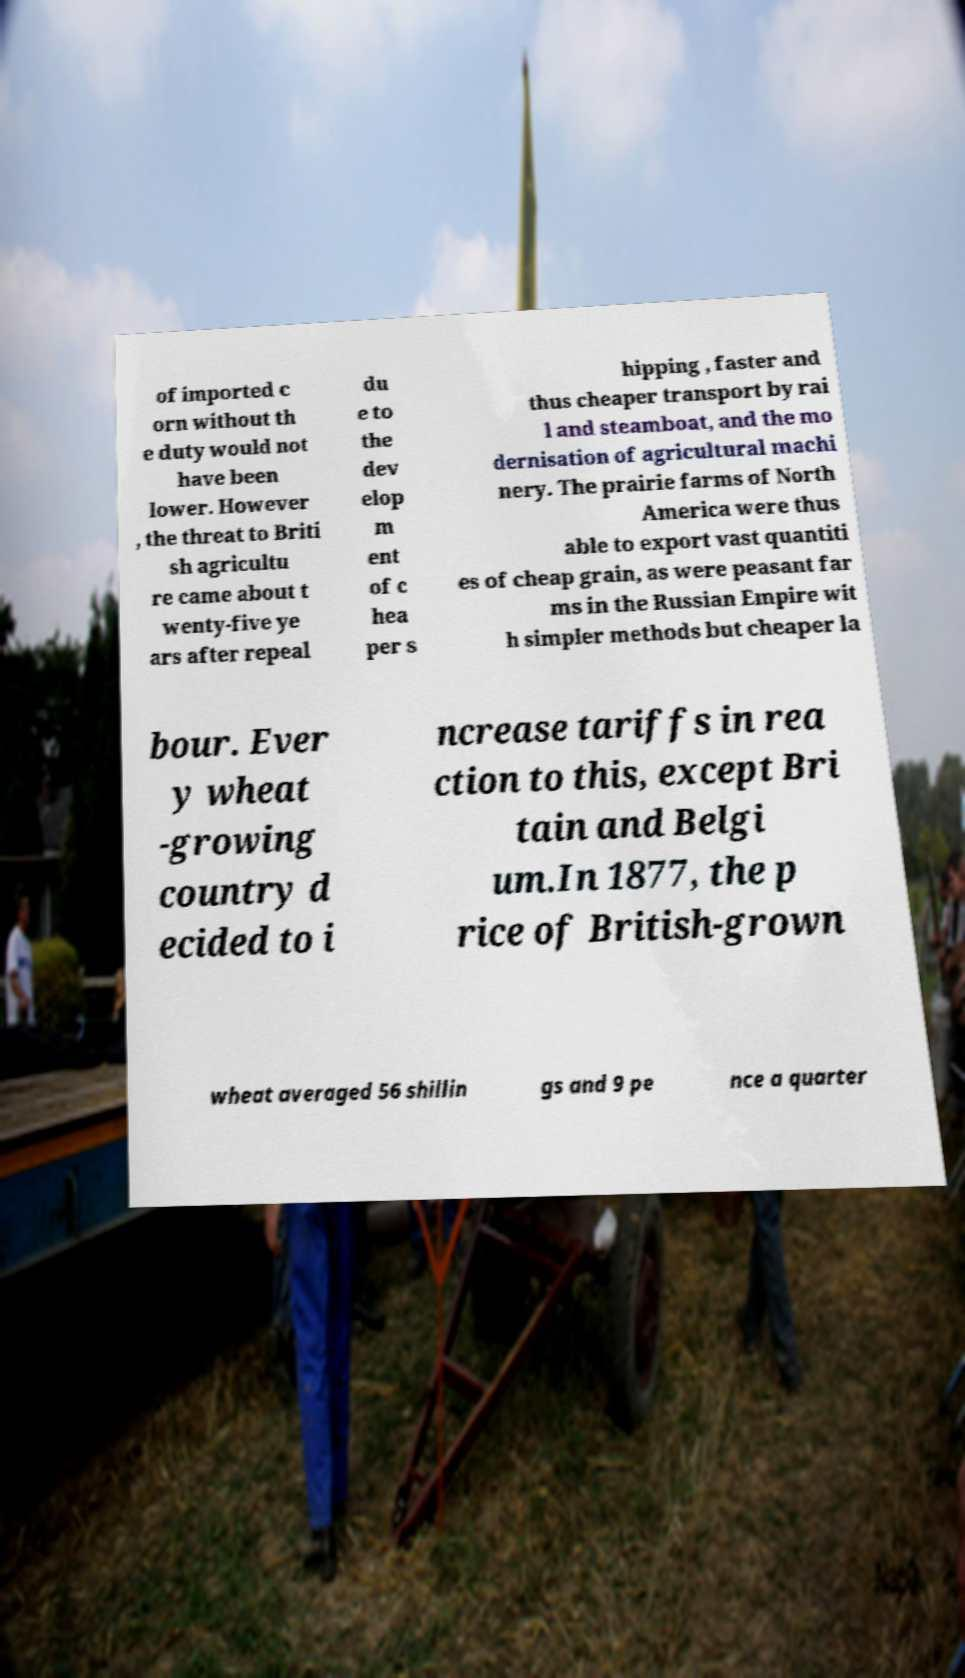Could you assist in decoding the text presented in this image and type it out clearly? of imported c orn without th e duty would not have been lower. However , the threat to Briti sh agricultu re came about t wenty-five ye ars after repeal du e to the dev elop m ent of c hea per s hipping , faster and thus cheaper transport by rai l and steamboat, and the mo dernisation of agricultural machi nery. The prairie farms of North America were thus able to export vast quantiti es of cheap grain, as were peasant far ms in the Russian Empire wit h simpler methods but cheaper la bour. Ever y wheat -growing country d ecided to i ncrease tariffs in rea ction to this, except Bri tain and Belgi um.In 1877, the p rice of British-grown wheat averaged 56 shillin gs and 9 pe nce a quarter 